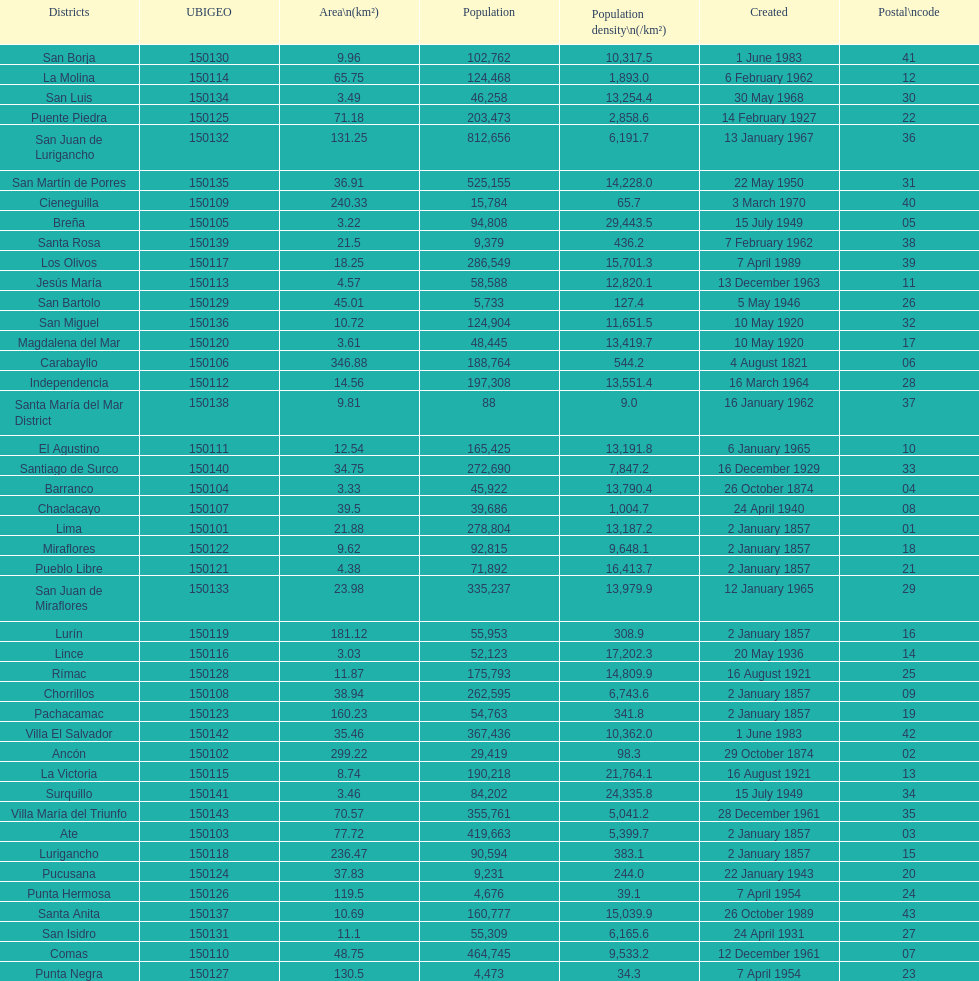Which is the largest district in terms of population? San Juan de Lurigancho. 